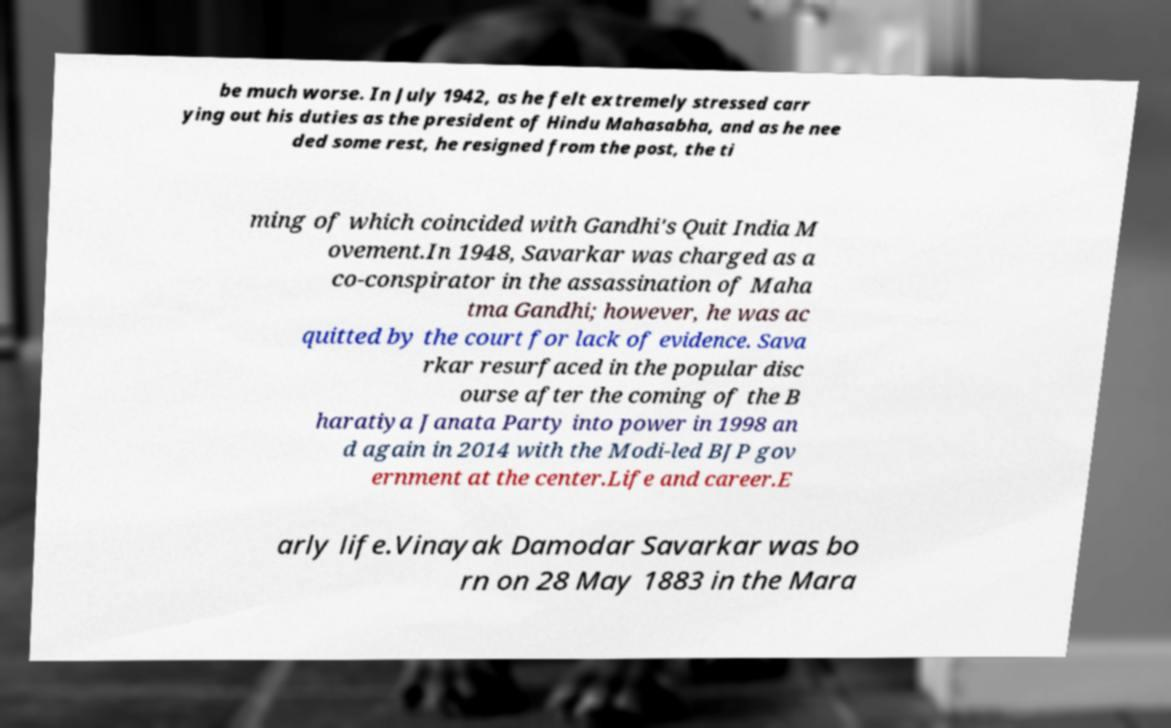There's text embedded in this image that I need extracted. Can you transcribe it verbatim? be much worse. In July 1942, as he felt extremely stressed carr ying out his duties as the president of Hindu Mahasabha, and as he nee ded some rest, he resigned from the post, the ti ming of which coincided with Gandhi's Quit India M ovement.In 1948, Savarkar was charged as a co-conspirator in the assassination of Maha tma Gandhi; however, he was ac quitted by the court for lack of evidence. Sava rkar resurfaced in the popular disc ourse after the coming of the B haratiya Janata Party into power in 1998 an d again in 2014 with the Modi-led BJP gov ernment at the center.Life and career.E arly life.Vinayak Damodar Savarkar was bo rn on 28 May 1883 in the Mara 